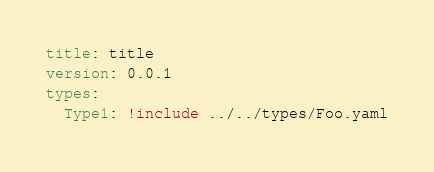Convert code to text. <code><loc_0><loc_0><loc_500><loc_500><_YAML_>title: title
version: 0.0.1
types:
  Type1: !include ../../types/Foo.yaml
</code> 